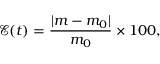Convert formula to latex. <formula><loc_0><loc_0><loc_500><loc_500>\mathcal { E } ( t ) = \frac { | m - m _ { 0 } | } { m _ { 0 } } \times 1 0 0 ,</formula> 